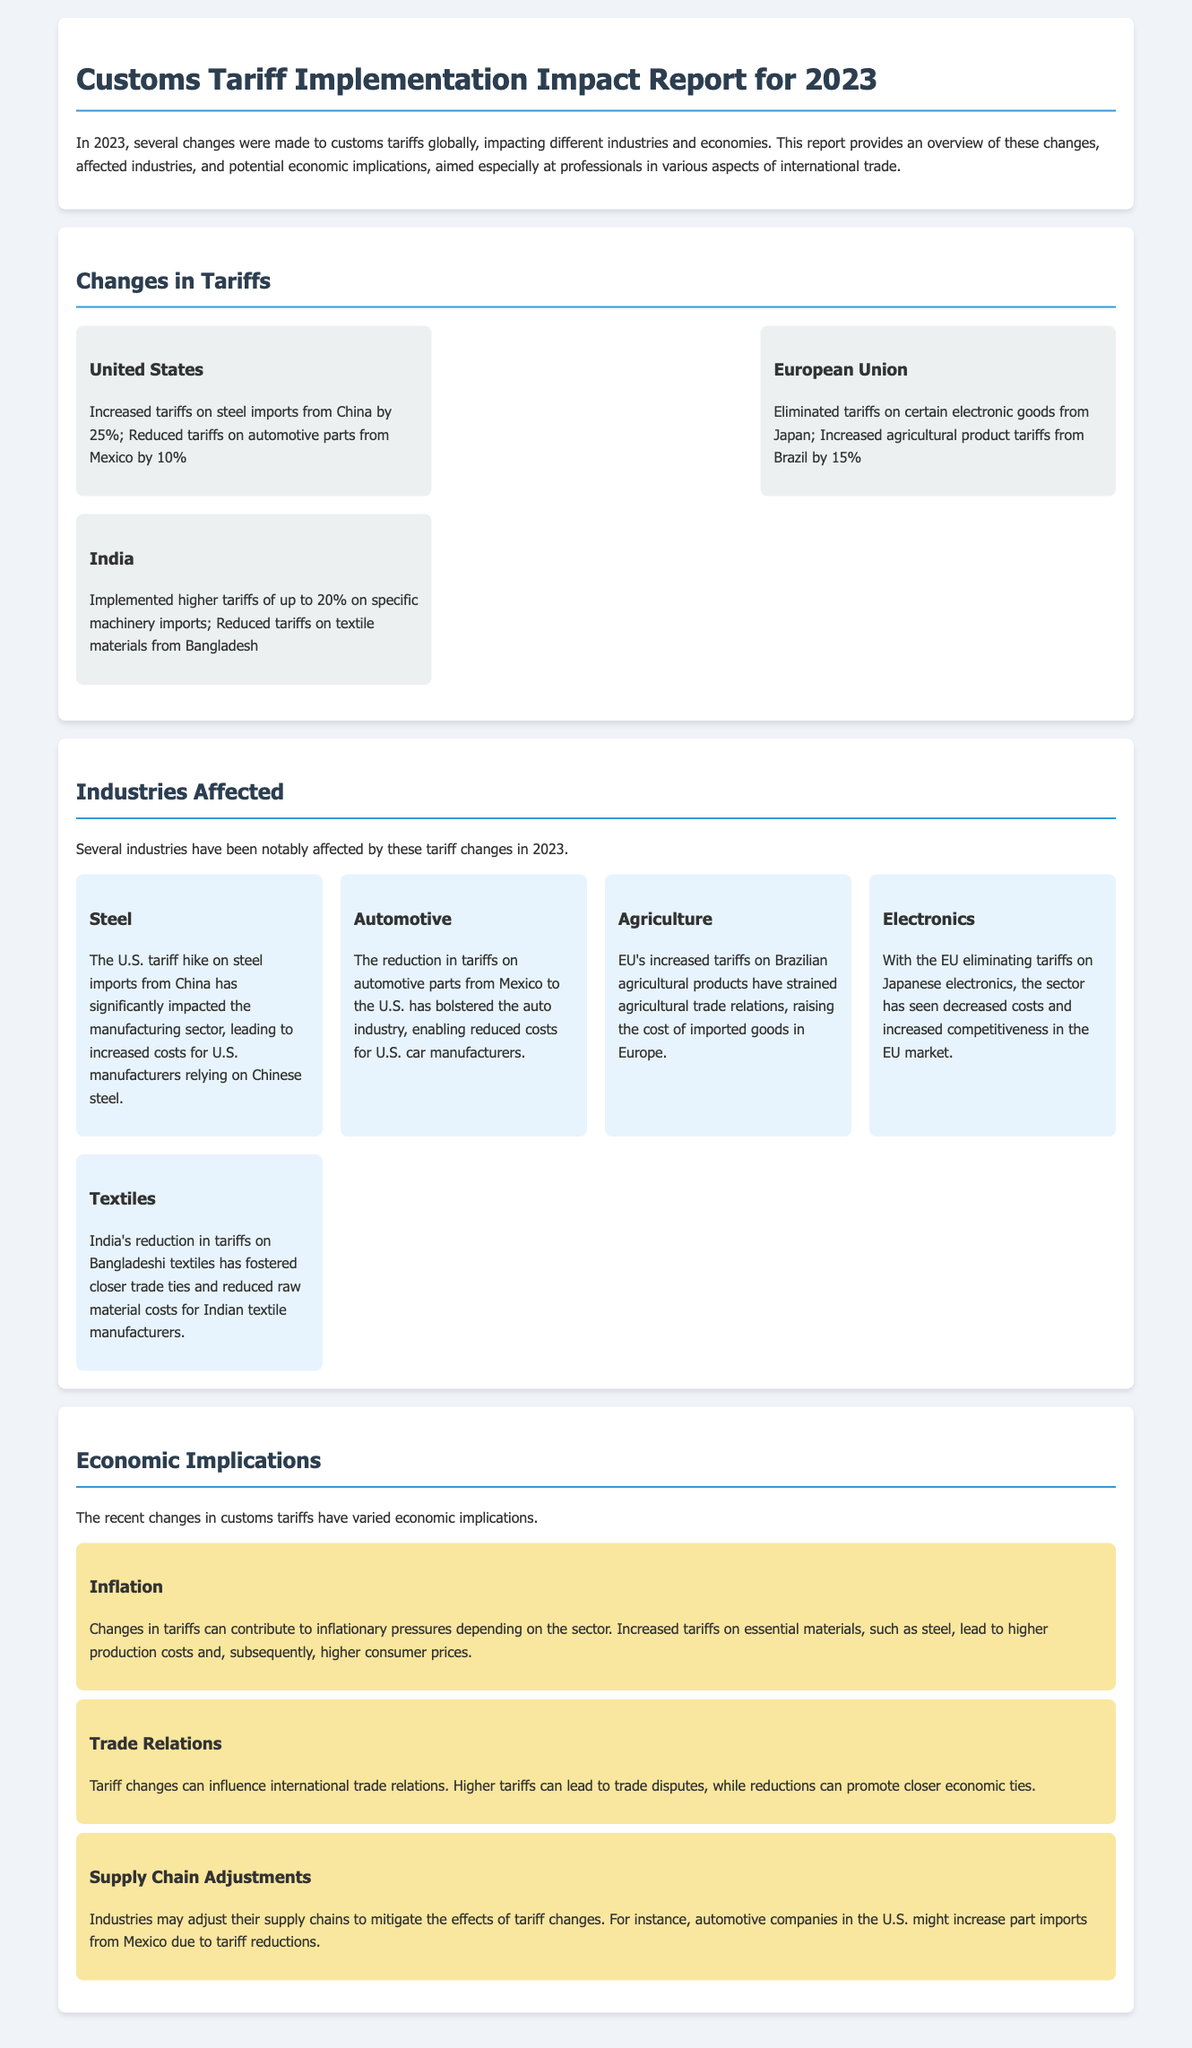What were the increased tariffs on steel imports from China by the United States? The document states that the U.S. increased tariffs on steel imports from China by 25%.
Answer: 25% Which country eliminated tariffs on certain electronic goods? The document mentions that the European Union eliminated tariffs on certain electronic goods from Japan.
Answer: European Union What industry is impacted by the EU's increased tariffs on Brazilian agricultural products? The document indicates that agriculture is the industry strained by the EU's increased tariffs on Brazilian agricultural products.
Answer: Agriculture What is one economic implication related to inflation mentioned in the report? The document states that increased tariffs on essential materials can lead to higher production costs and higher consumer prices.
Answer: Higher production costs Which country reduced tariffs on textiles from Bangladesh? The document states that India reduced tariffs on textile materials from Bangladesh.
Answer: India What was the impact of reduced tariffs on automotive parts from Mexico to the U.S.? The report indicates that the reduction has bolstered the auto industry by enabling reduced costs for U.S. car manufacturers.
Answer: Bolstered the auto industry What percentage were the increased tariffs on specific machinery imports in India? The document mentions that India implemented higher tariffs of up to 20% on specific machinery imports.
Answer: 20% How did tariff changes affect supply chains according to the report? The document notes that industries may adjust their supply chains to mitigate the effects of tariff changes, especially in the automotive sector.
Answer: Adjust their supply chains 